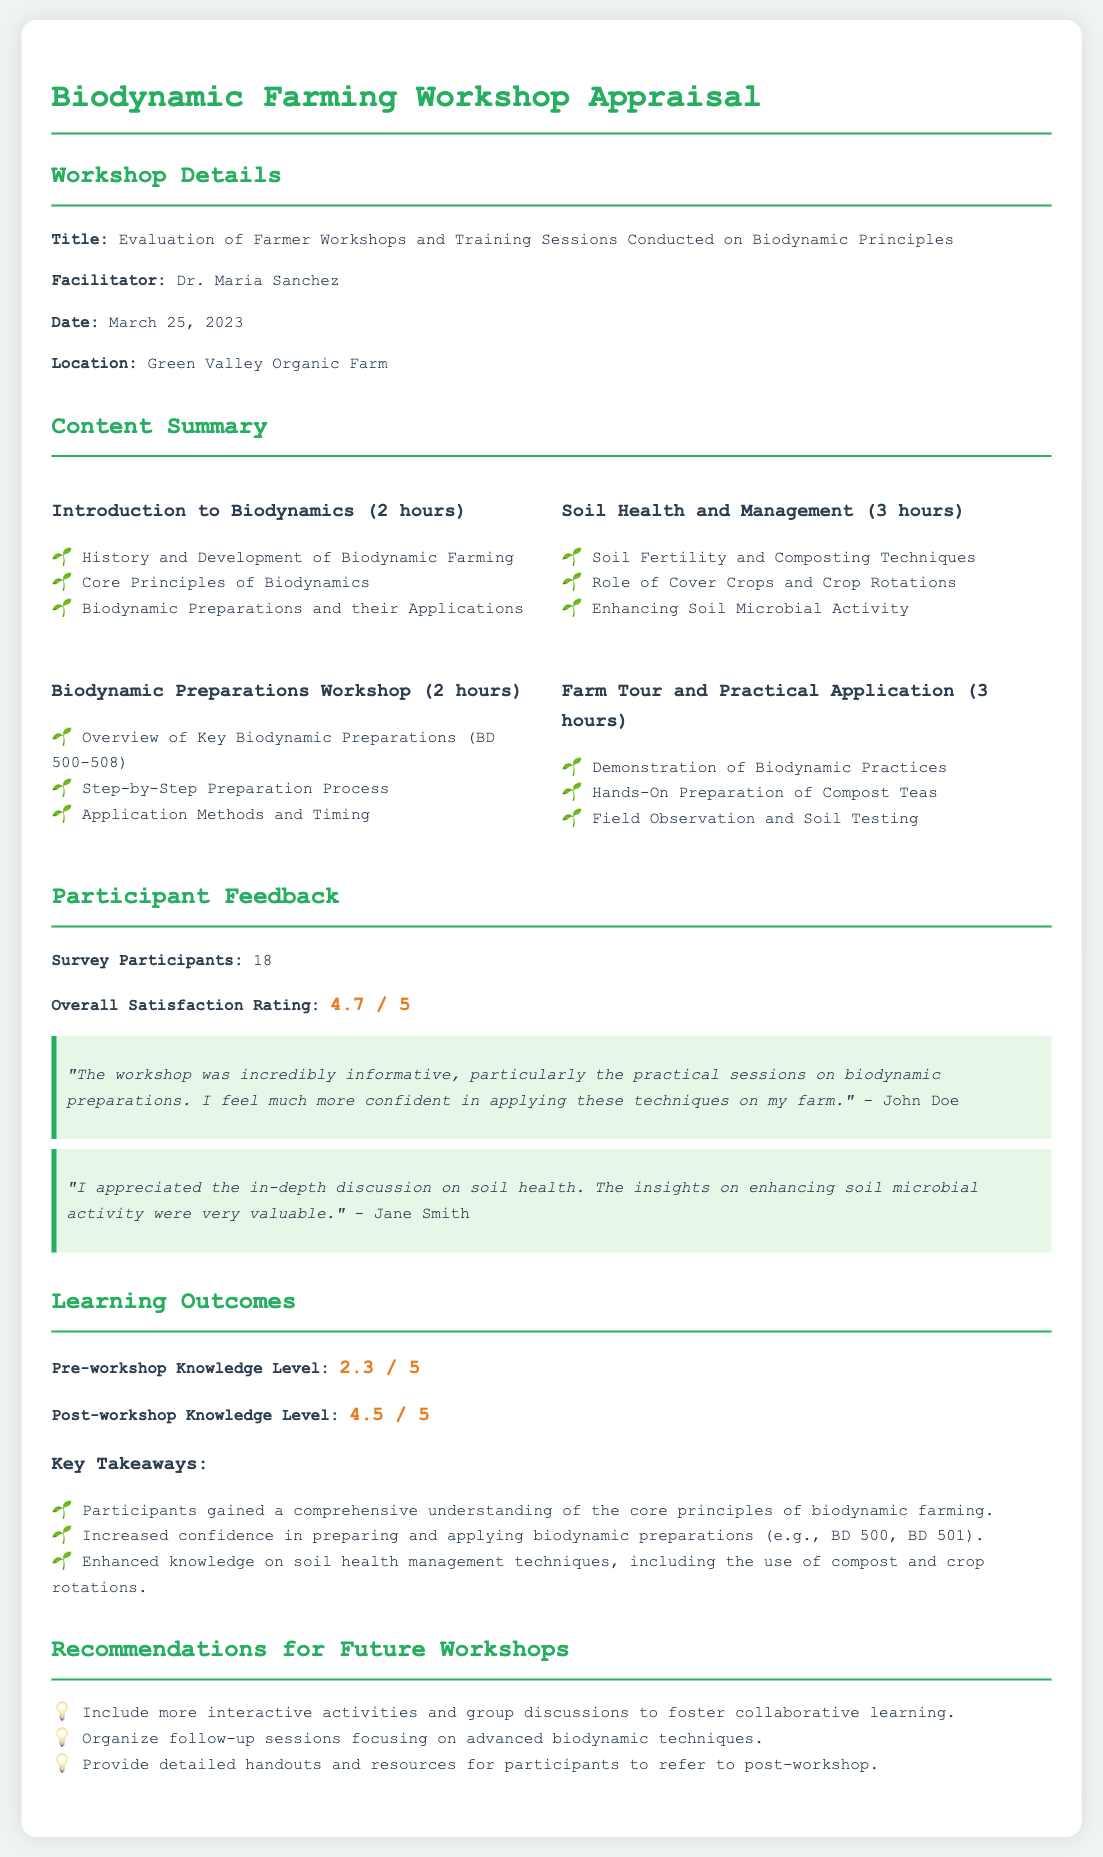What is the title of the workshop? The title of the workshop is stated in the document under Workshop Details.
Answer: Evaluation of Farmer Workshops and Training Sessions Conducted on Biodynamic Principles Who was the facilitator of the workshop? The facilitator is mentioned in the Workshop Details section.
Answer: Dr. Maria Sanchez What was the overall satisfaction rating from participants? The overall satisfaction rating is noted in the Participant Feedback section.
Answer: 4.7 / 5 How many participants were surveyed? The number of survey participants is provided in the Participant Feedback section.
Answer: 18 What was the pre-workshop knowledge level rating? The pre-workshop knowledge level is mentioned under Learning Outcomes.
Answer: 2.3 / 5 What are the key takeaways mentioned in the Learning Outcomes? The key takeaways are listed in a bullet format in the Learning Outcomes section.
Answer: Comprehensive understanding of the core principles of biodynamic farming What is one recommendation for future workshops? Recommendations for future workshops are provided in the corresponding section.
Answer: Include more interactive activities and group discussions to foster collaborative learning How many hours was the Soil Health and Management session? The duration of the session is indicated in the Content Summary section.
Answer: 3 hours What practical skills did participants gain from the workshop? Practical skills are implied through the content provided, specifically in the Biodynamic Preparations Workshop.
Answer: Preparing and applying biodynamic preparations 